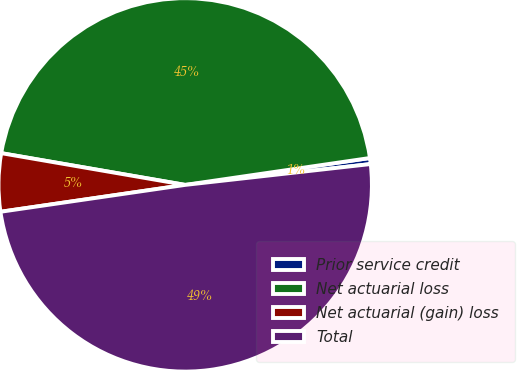<chart> <loc_0><loc_0><loc_500><loc_500><pie_chart><fcel>Prior service credit<fcel>Net actuarial loss<fcel>Net actuarial (gain) loss<fcel>Total<nl><fcel>0.52%<fcel>44.98%<fcel>5.02%<fcel>49.48%<nl></chart> 